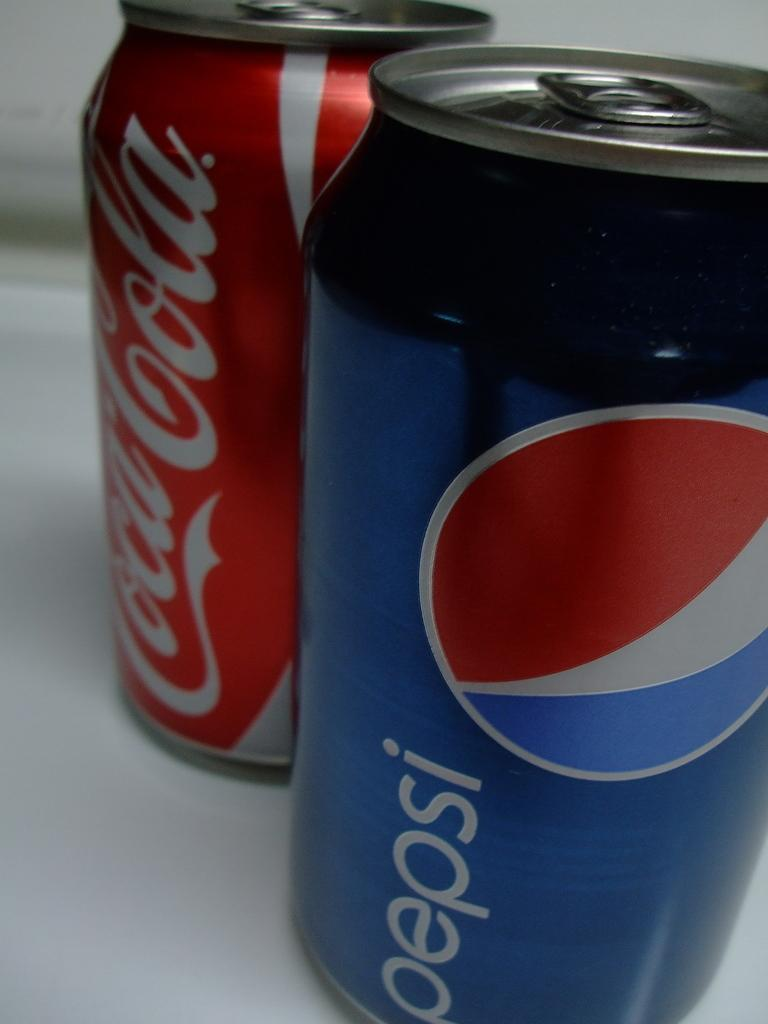<image>
Relay a brief, clear account of the picture shown. A Pepsi and a Coca Cola sitting side by side 